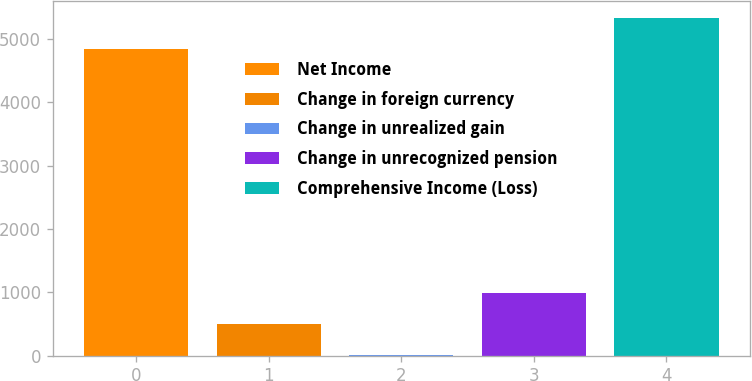Convert chart to OTSL. <chart><loc_0><loc_0><loc_500><loc_500><bar_chart><fcel>Net Income<fcel>Change in foreign currency<fcel>Change in unrealized gain<fcel>Change in unrecognized pension<fcel>Comprehensive Income (Loss)<nl><fcel>4844<fcel>495.2<fcel>6<fcel>984.4<fcel>5333.2<nl></chart> 